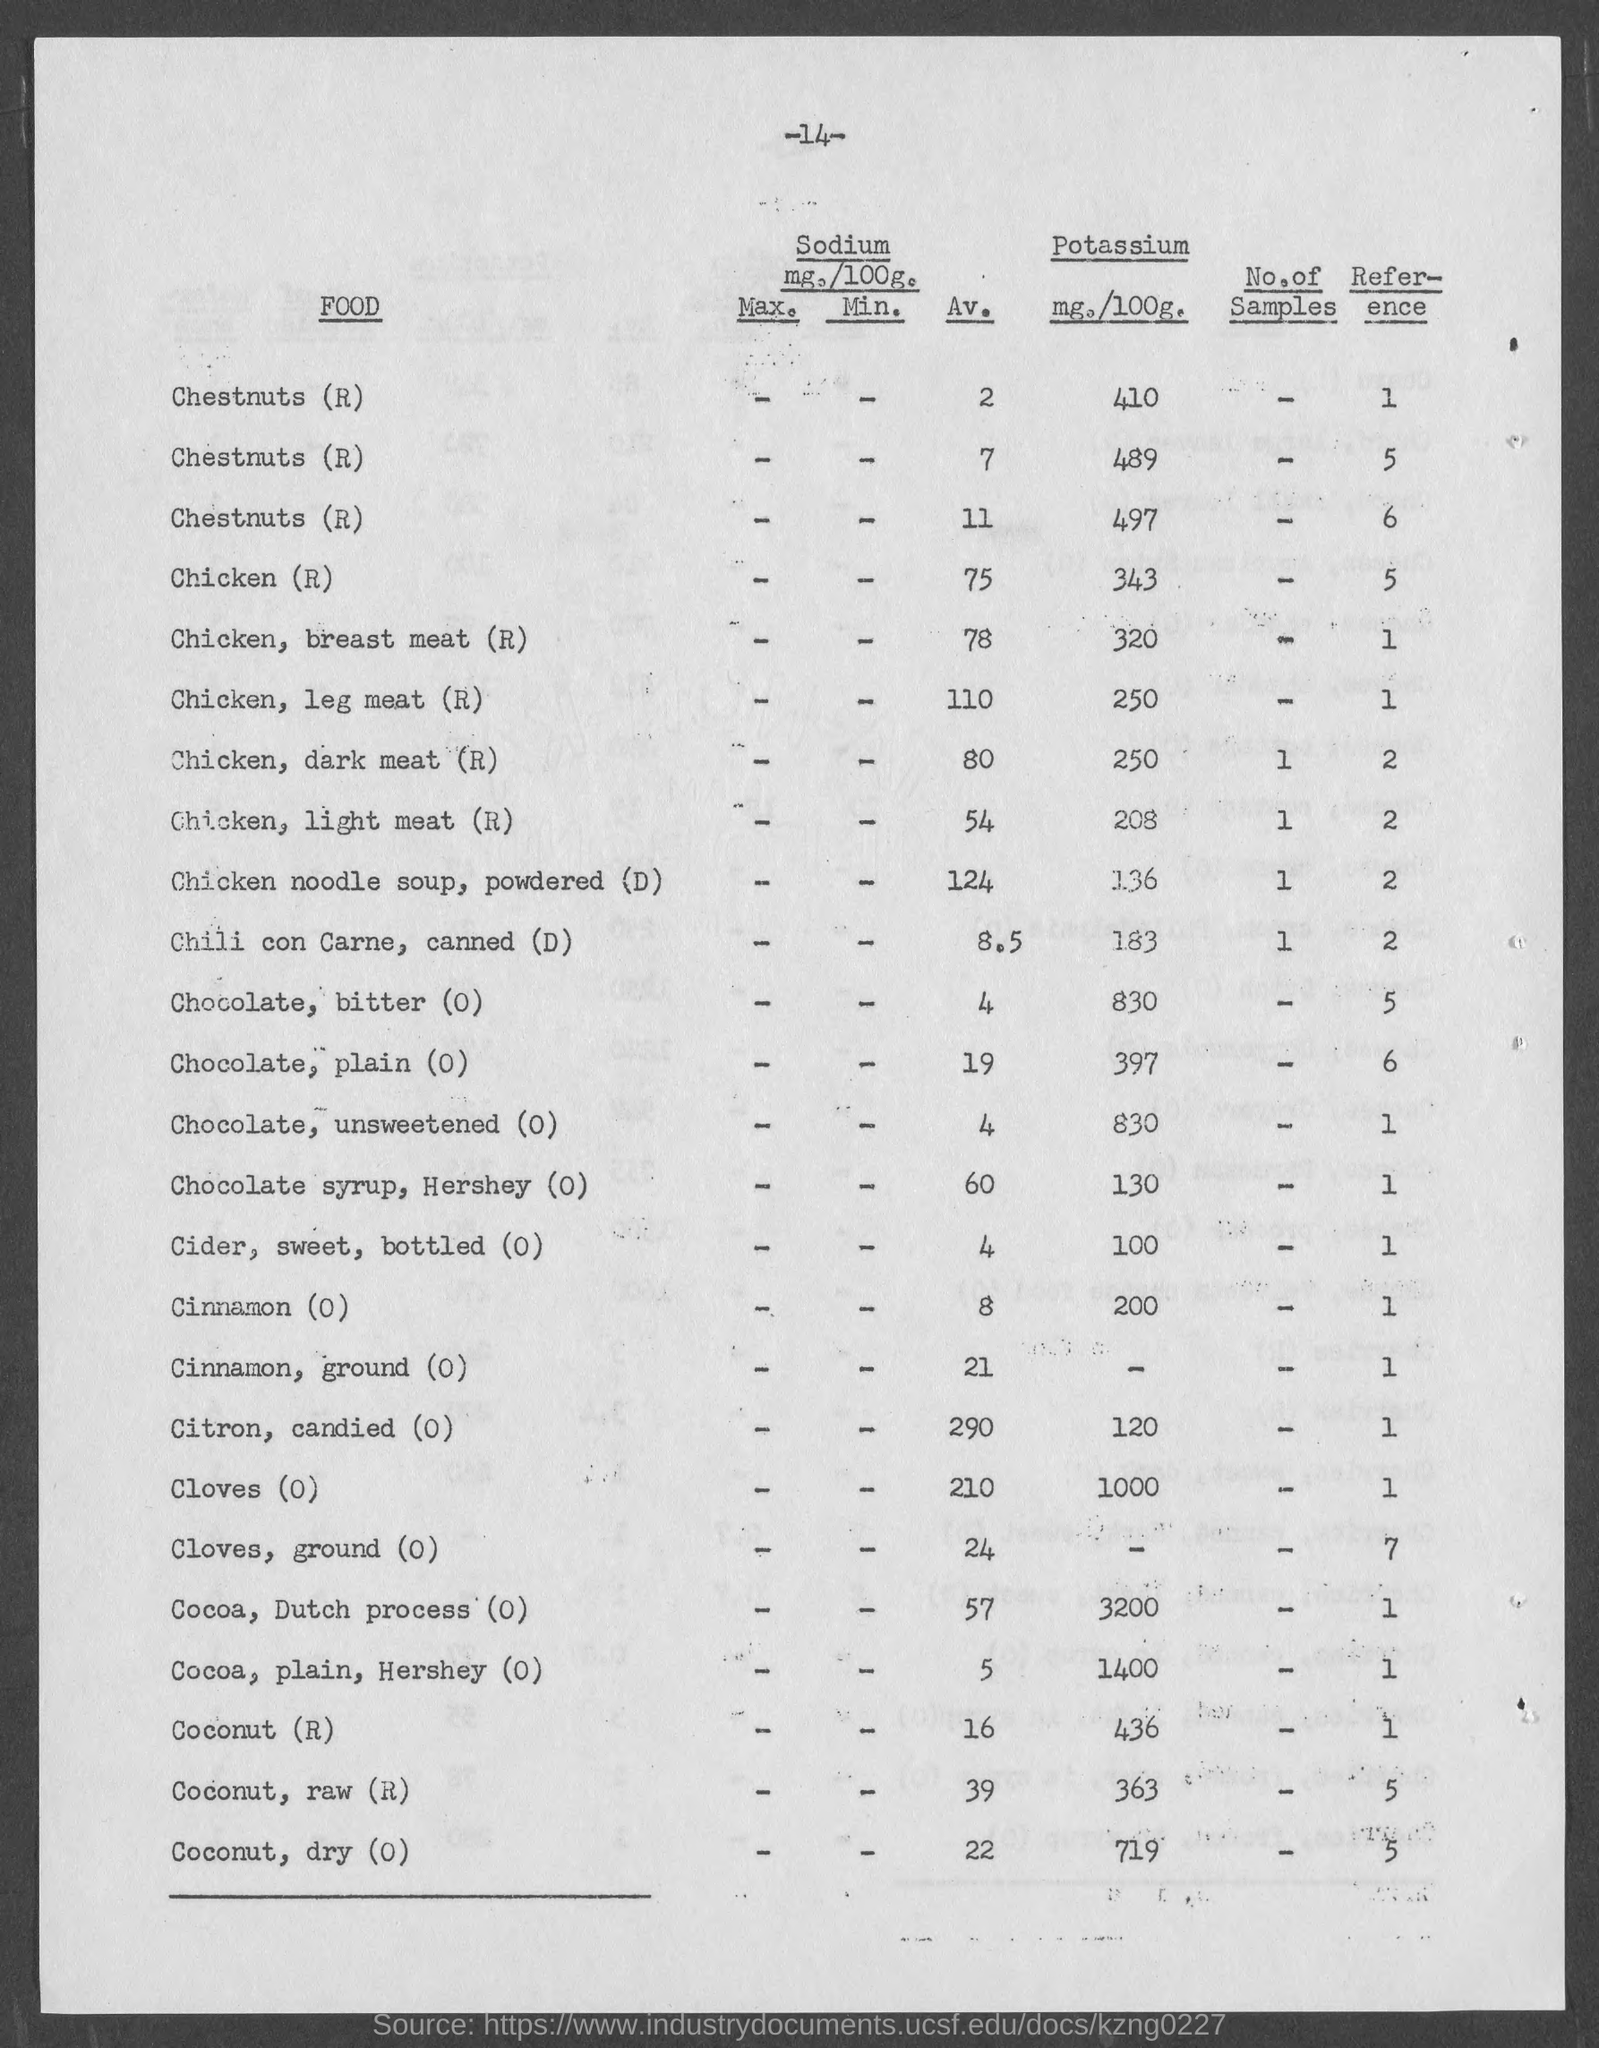What is the number at top of the page ?
Offer a very short reply. -14-. What is the amount of potassium mg./100g. of chicken (r)?
Make the answer very short. 343 mg. What is the amount of potassium mg./100g. of chicken, breast meat (r)?
Your answer should be compact. 320 mg. What is the amount of potassium mg./100g. of chicken, leg meat (r)?
Provide a succinct answer. 250. What is the amount of potassium mg./100g. of chicken, dark meat(r)?
Give a very brief answer. 250 mg. What is the amount of potassium mg./100g. of chicken, light meat?
Offer a very short reply. 208 mg. What is the amount of potassium mg./100g. of  chicken noodle soup, powdered (d)?
Your answer should be compact. 136. What is the amount of potassium mg./100g. of chili con carne, canned (d)?
Your answer should be compact. 183. What is the amount of potassium mg./100g. of chocolate, bitter (o)?
Your response must be concise. 830 mg. What is the amount of potassium mg./100g. of chocolate, plain (o)?
Provide a short and direct response. 397 mg. 